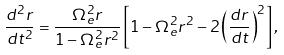<formula> <loc_0><loc_0><loc_500><loc_500>\frac { d ^ { 2 } r } { d t ^ { 2 } } = \frac { \Omega _ { e } ^ { 2 } r } { 1 - \Omega _ { e } ^ { 2 } r ^ { 2 } } \left [ 1 - \Omega _ { e } ^ { 2 } r ^ { 2 } - 2 \left ( \frac { d r } { d t } \right ) ^ { 2 } \right ] ,</formula> 